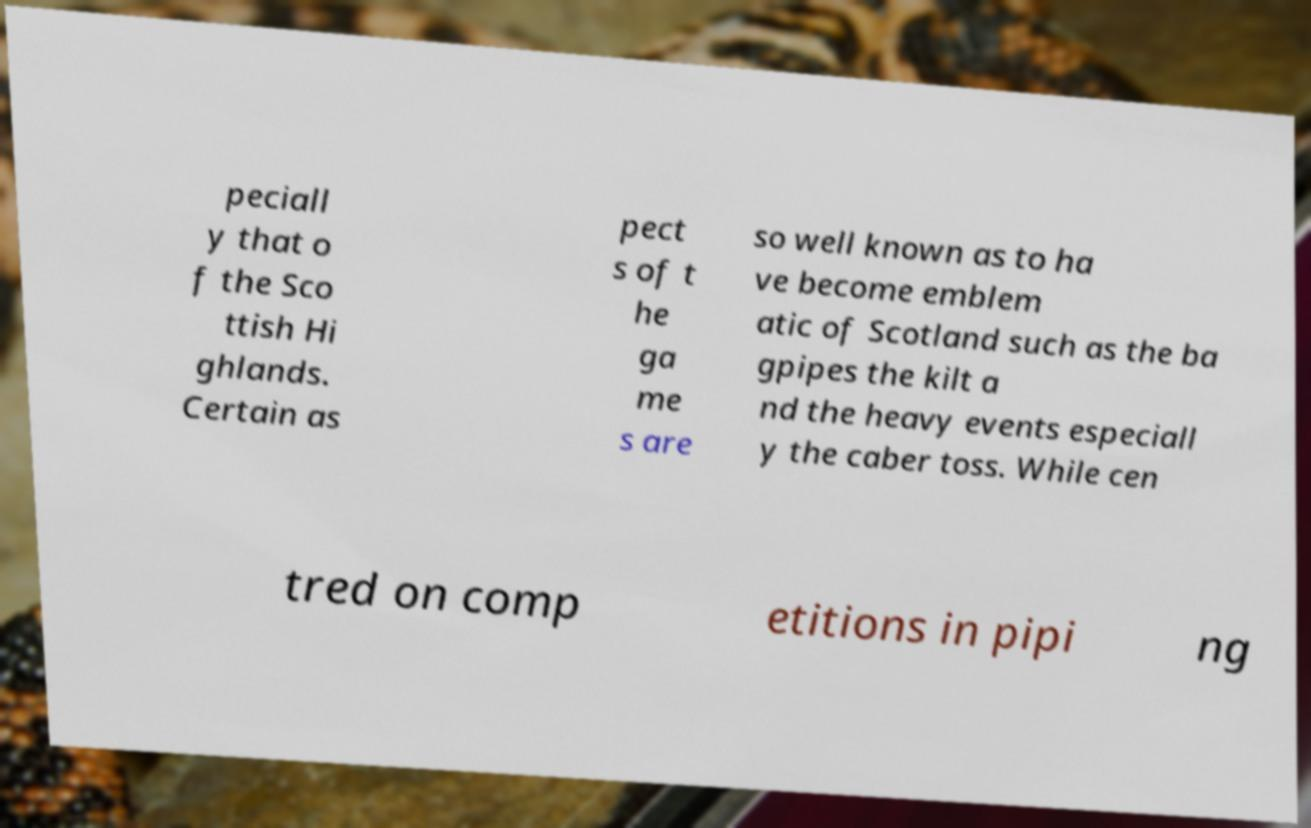Can you read and provide the text displayed in the image?This photo seems to have some interesting text. Can you extract and type it out for me? peciall y that o f the Sco ttish Hi ghlands. Certain as pect s of t he ga me s are so well known as to ha ve become emblem atic of Scotland such as the ba gpipes the kilt a nd the heavy events especiall y the caber toss. While cen tred on comp etitions in pipi ng 